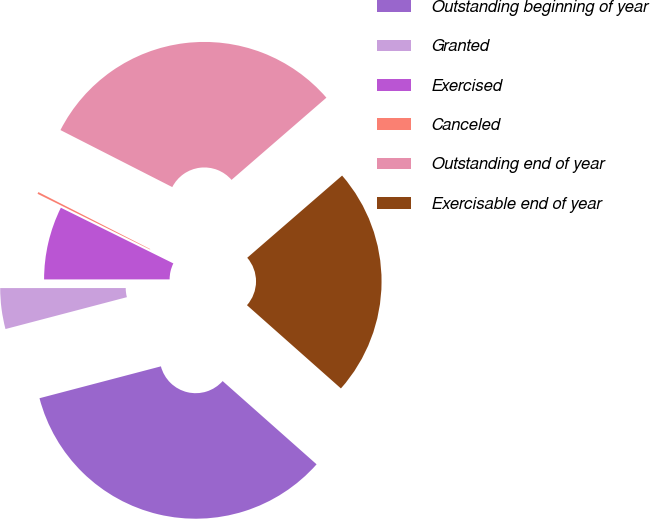Convert chart to OTSL. <chart><loc_0><loc_0><loc_500><loc_500><pie_chart><fcel>Outstanding beginning of year<fcel>Granted<fcel>Exercised<fcel>Canceled<fcel>Outstanding end of year<fcel>Exercisable end of year<nl><fcel>34.37%<fcel>4.08%<fcel>7.32%<fcel>0.19%<fcel>31.13%<fcel>22.9%<nl></chart> 